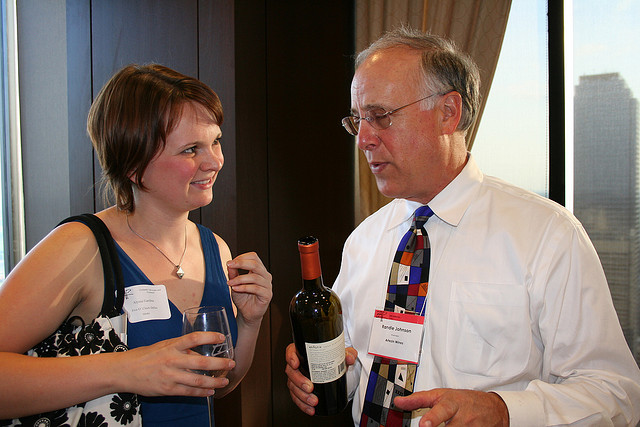<image>What accessory is in the woman's hair? There is no accessory in the woman's hair. It could possibly be a clip or a hair tie. What restaurant logo is on the man's shirt in the middle? It is uncertain what restaurant logo is on the man's shirt in the middle. It could be 'montegos', 'sonic', or "applebee's". But, it can also be seen no logo. What accessory is in the woman's hair? It can be seen that the woman doesn't have any accessory in her hair. What restaurant logo is on the man's shirt in the middle? I don't know what restaurant logo is on the man's shirt in the middle. There is no clear logo visible. 